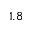<formula> <loc_0><loc_0><loc_500><loc_500>1 . 8</formula> 